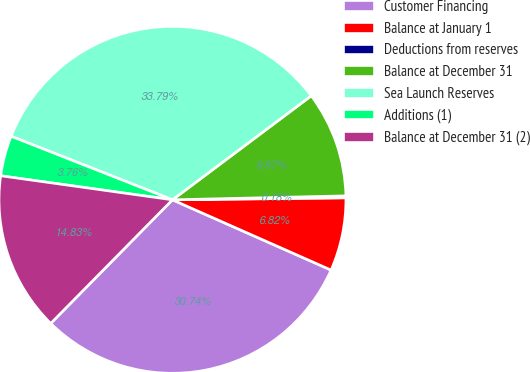<chart> <loc_0><loc_0><loc_500><loc_500><pie_chart><fcel>Customer Financing<fcel>Balance at January 1<fcel>Deductions from reserves<fcel>Balance at December 31<fcel>Sea Launch Reserves<fcel>Additions (1)<fcel>Balance at December 31 (2)<nl><fcel>30.74%<fcel>6.82%<fcel>0.18%<fcel>9.87%<fcel>33.79%<fcel>3.76%<fcel>14.83%<nl></chart> 